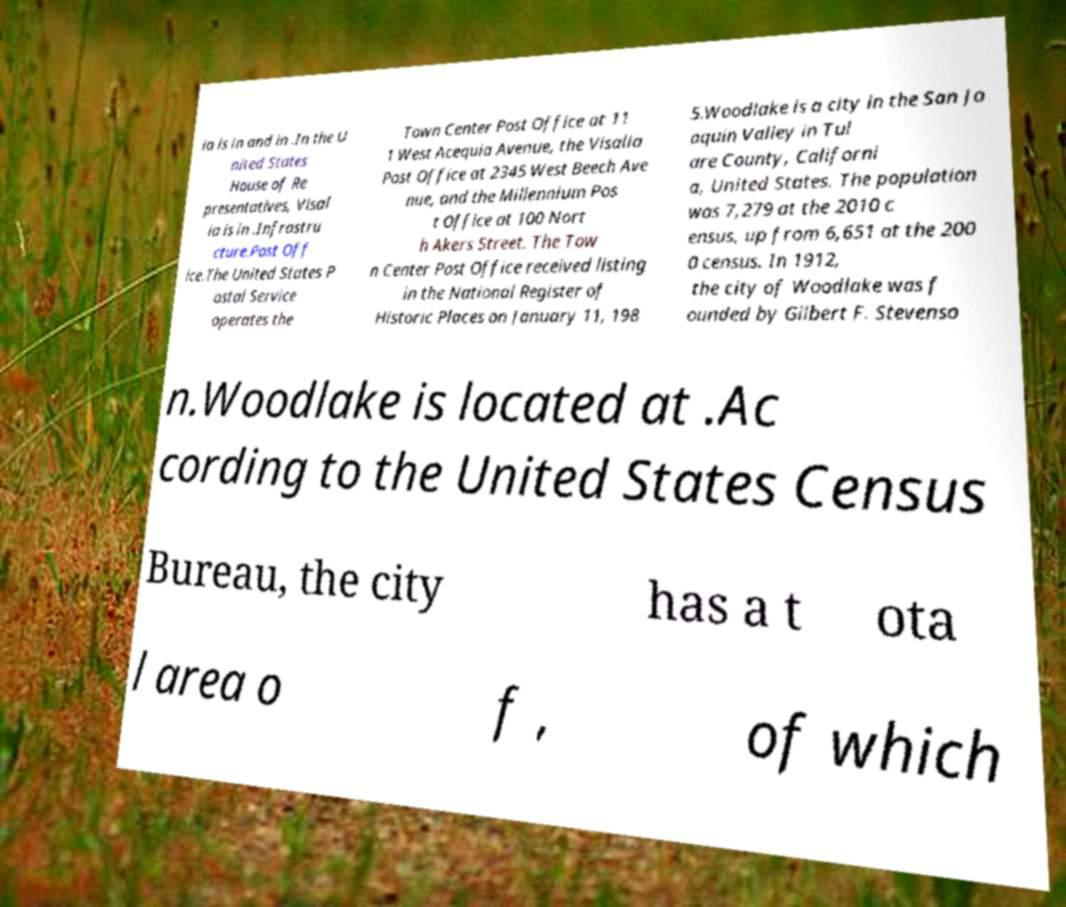Could you assist in decoding the text presented in this image and type it out clearly? ia is in and in .In the U nited States House of Re presentatives, Visal ia is in .Infrastru cture.Post Off ice.The United States P ostal Service operates the Town Center Post Office at 11 1 West Acequia Avenue, the Visalia Post Office at 2345 West Beech Ave nue, and the Millennium Pos t Office at 100 Nort h Akers Street. The Tow n Center Post Office received listing in the National Register of Historic Places on January 11, 198 5.Woodlake is a city in the San Jo aquin Valley in Tul are County, Californi a, United States. The population was 7,279 at the 2010 c ensus, up from 6,651 at the 200 0 census. In 1912, the city of Woodlake was f ounded by Gilbert F. Stevenso n.Woodlake is located at .Ac cording to the United States Census Bureau, the city has a t ota l area o f , of which 